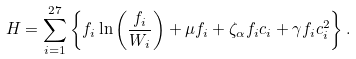Convert formula to latex. <formula><loc_0><loc_0><loc_500><loc_500>H = \sum _ { i = 1 } ^ { 2 7 } \left \{ f _ { i } \ln \left ( \frac { f _ { i } } { W _ { i } } \right ) + \mu f _ { i } + \zeta _ { \alpha } f _ { i } c _ { i } + \gamma f _ { i } c _ { i } ^ { 2 } \right \} .</formula> 